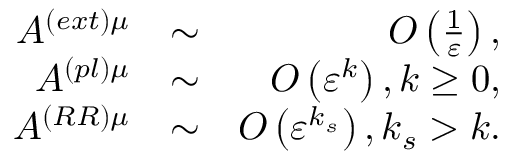Convert formula to latex. <formula><loc_0><loc_0><loc_500><loc_500>\begin{array} { r l r } { A ^ { \left ( e x t \right ) \mu } } & { \sim } & { O \left ( \frac { 1 } { \varepsilon } \right ) , } \\ { A ^ { \left ( p l \right ) \mu } } & { \sim } & { O \left ( \varepsilon ^ { k } \right ) , k \geq 0 , } \\ { A ^ { \left ( R R \right ) \mu } } & { \sim } & { O \left ( \varepsilon ^ { k _ { s } } \right ) , k _ { s } > k . } \end{array}</formula> 